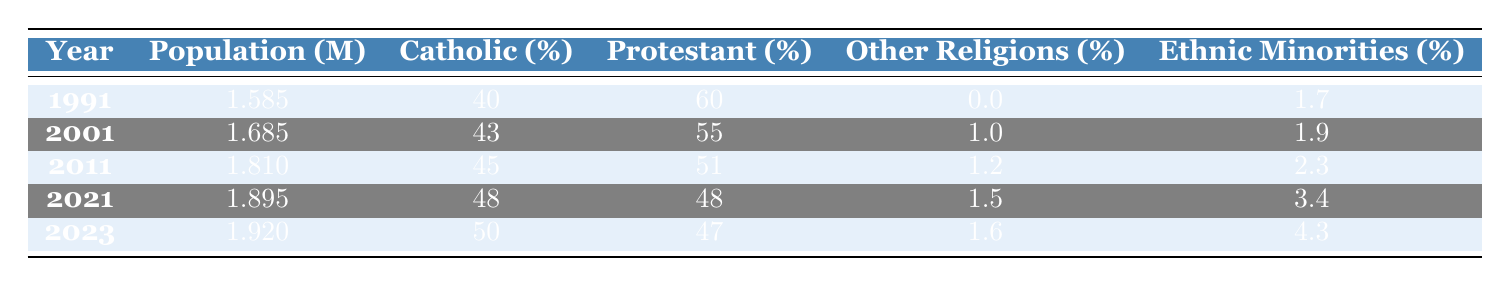What was the population of Northern Ireland in 1991? According to the table, the population listed for the year 1991 is 1.585 million.
Answer: 1.585 million What percentage of the population identified as Catholic in 2021? The table shows that in 2021, 48% of the population identified as Catholic.
Answer: 48% What is the percentage of Protestants in 2001? By checking the table for the year 2001, the percentage of Protestants is listed as 55%.
Answer: 55% In which year was the percentage of Catholics in Northern Ireland first greater than 45%? By examining the table, the percentage of Catholics first exceeds 45% in the year 2011, where it is 45%.
Answer: 2011 What was the change in the percentage of ethnic minorities from 1991 to 2023? The percentage of ethnic minorities in 1991 was 1.7%, and in 2023 it is 4.3%. The change is calculated by subtracting 1.7% from 4.3%, resulting in a change of 2.6%.
Answer: 2.6% How many more people identified as Catholic than Protestant in 2023? In 2023, there are 50% Catholics and 47% Protestants. The difference is 50% - 47% = 3%.
Answer: 3% What is the median percentage of Catholics over the years provided? The percentages of Catholics over the five years (1991, 2001, 2011, 2021, 2023) are 40%, 43%, 45%, 48%, and 50%. The median is the middle value when sorted: 43% is the second value and 48% is the fourth value. The median is the average of these two: (43% + 48%) / 2 = 45.5%.
Answer: 45.5% Was the percentage of other religions higher in 2001 or 2011? In 2001, the percentage of other religions is 1.0%, while in 2011 it increased to 1.2%. Since 1.2% is greater than 1.0%, the percentage was higher in 2011.
Answer: Yes, in 2011 Which year had the highest population? The year with the highest population listed in the table is 2023, with a population of 1.920 million.
Answer: 2023 If we consider the percentage of Catholics and Protestants together in 2023, what do they add up to? In 2023, 50% of the population identified as Catholic and 47% as Protestant. Adding these percentages together gives 50% + 47% = 97%.
Answer: 97% 